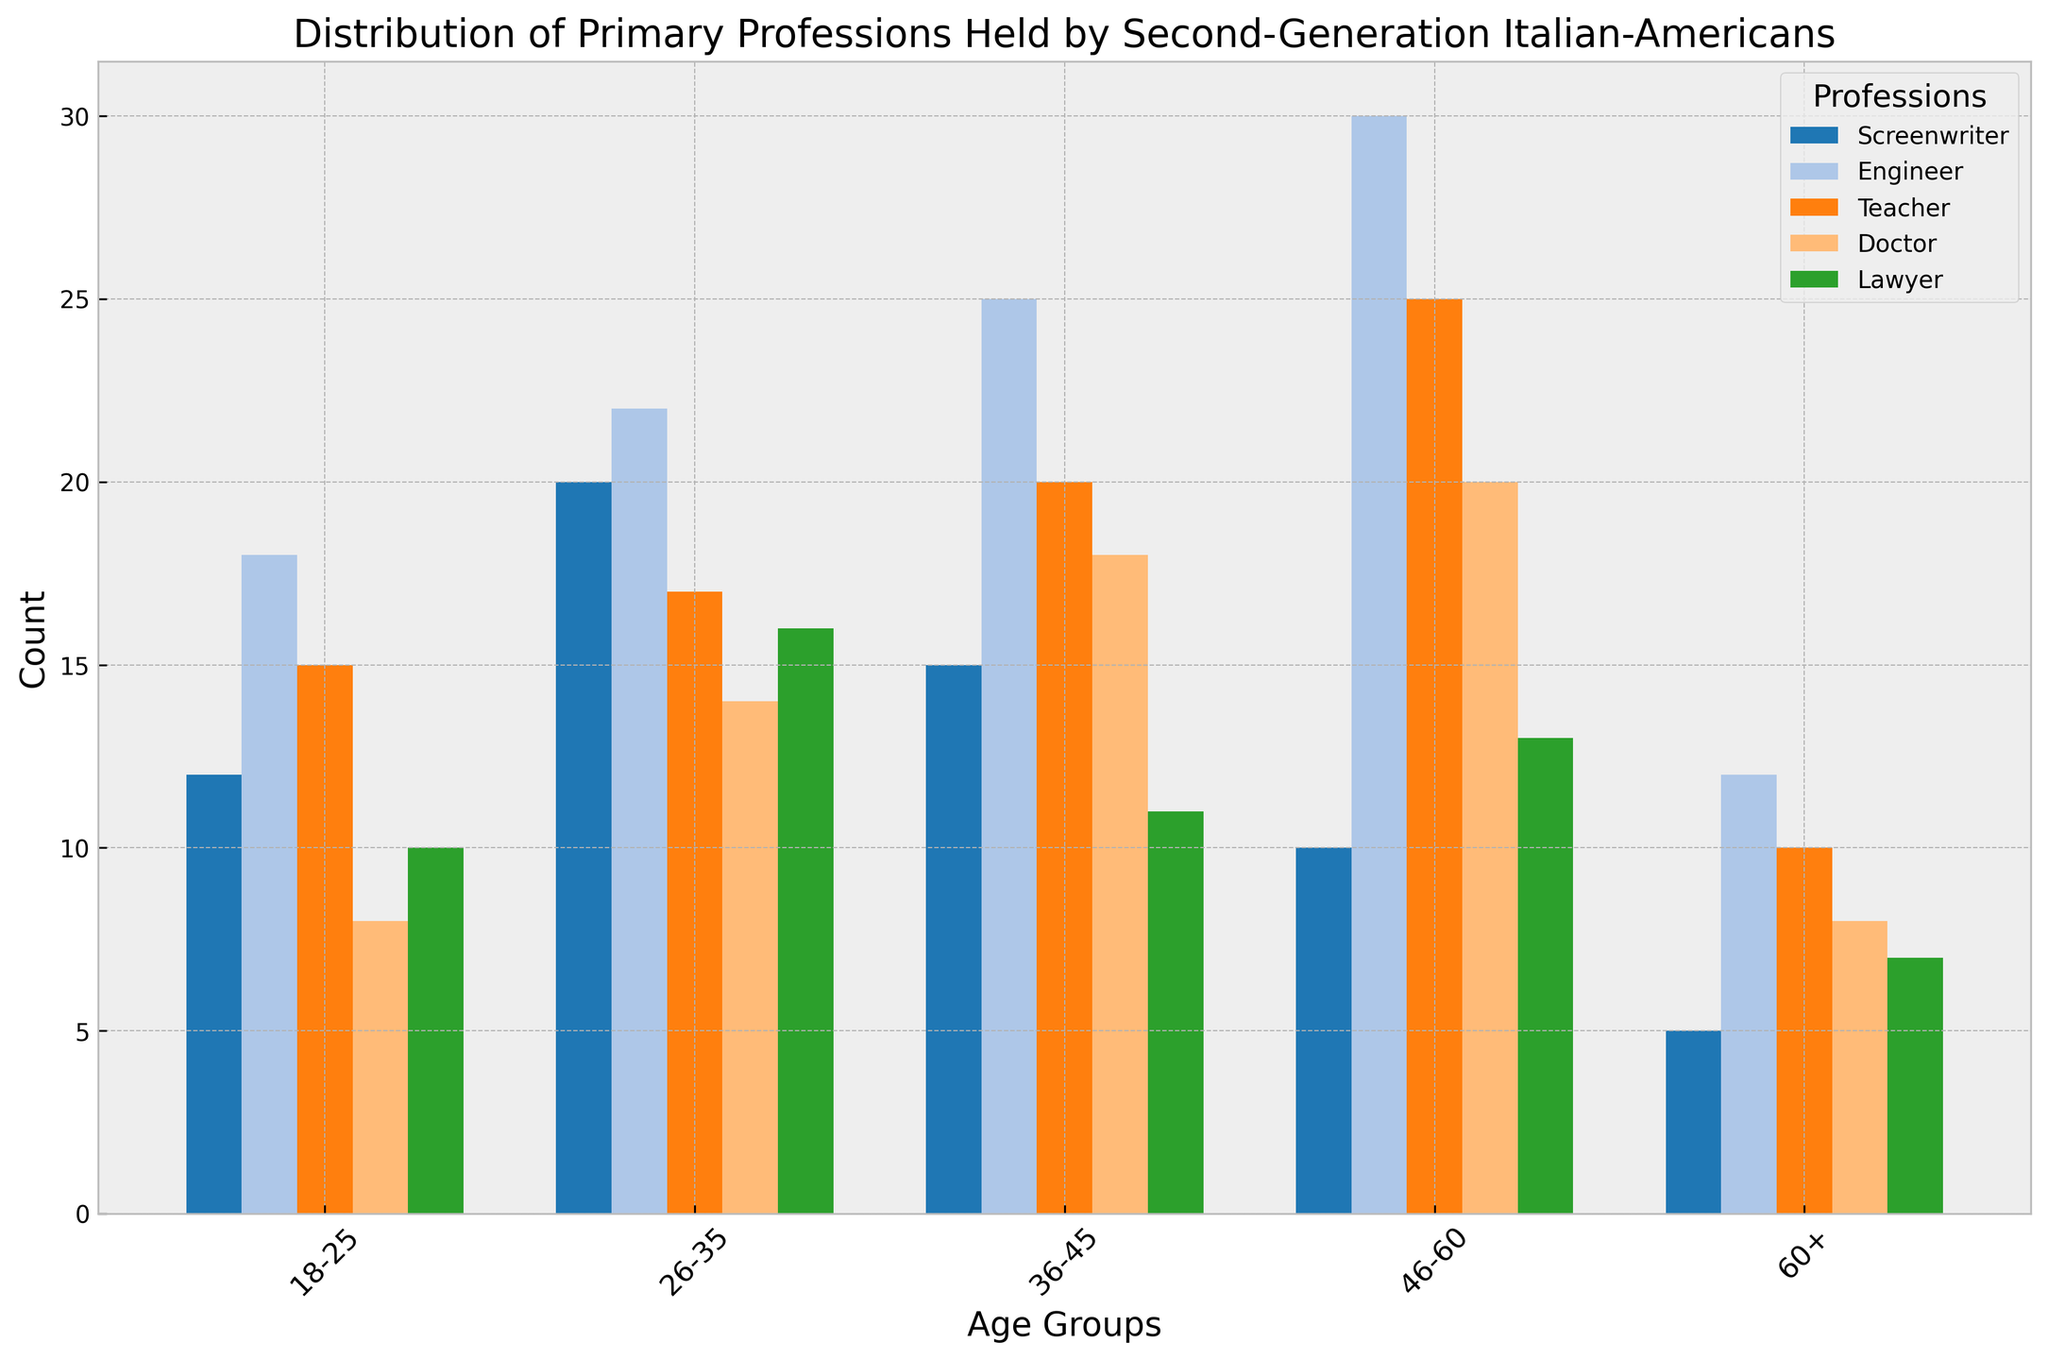Which profession has the highest count in the age group 46-60? To determine this, we look at the bars representing each profession within the 46-60 age group and identify the tallest one. The Engineer profession has the highest count in this group.
Answer: Engineer What is the total count of Screenwriters across all age groups? Sum the counts of the Screenwriter profession across all age groups: 12 (18-25) + 20 (26-35) + 15 (36-45) + 10 (46-60) + 5 (60+). This equals 62.
Answer: 62 Which age group has the highest number of Doctors? Compare the heights of the bars representing Doctors across all age groups. The highest bar is in the 46-60 age group.
Answer: 46-60 Is the number of Teachers in the 18-25 age group greater than the number of Lawyers in the same age group? Compare the heights of the bars representing Teachers and Lawyers in the 18-25 age group. The bar for Teachers is taller, indicating a higher count.
Answer: Yes What is the difference in the count of Engineers between the age groups 26-35 and 60+? Calculate the difference by subtracting the count of Engineers in the 60+ age group from that in the 26-35 age group: 22 (26-35) - 12 (60+) = 10.
Answer: 10 Which profession has the most uniform distribution across all age groups? Observe the height variability of each profession's bars across all age groups. The height of the bars for the Teacher profession varies the least.
Answer: Teacher In which age group do we see the least number of Screenwriters? Identify the smallest bar for Screenwriters across all age groups, which is in the 60+ age group.
Answer: 60+ How many more Engineers are there in the 46-60 age group compared to the 18-25 age group? Subtract the count of Engineers in the 18-25 age group from the count in the 46-60 age group: 30 (46-60) - 18 (18-25) = 12.
Answer: 12 Is the count of Doctors in the age group 36-45 higher than the count of Screenwriters in the age group 46-60? Compare the heights of the bars representing Doctors (36-45) and Screenwriters (46-60). The bar for Doctors is taller.
Answer: Yes 